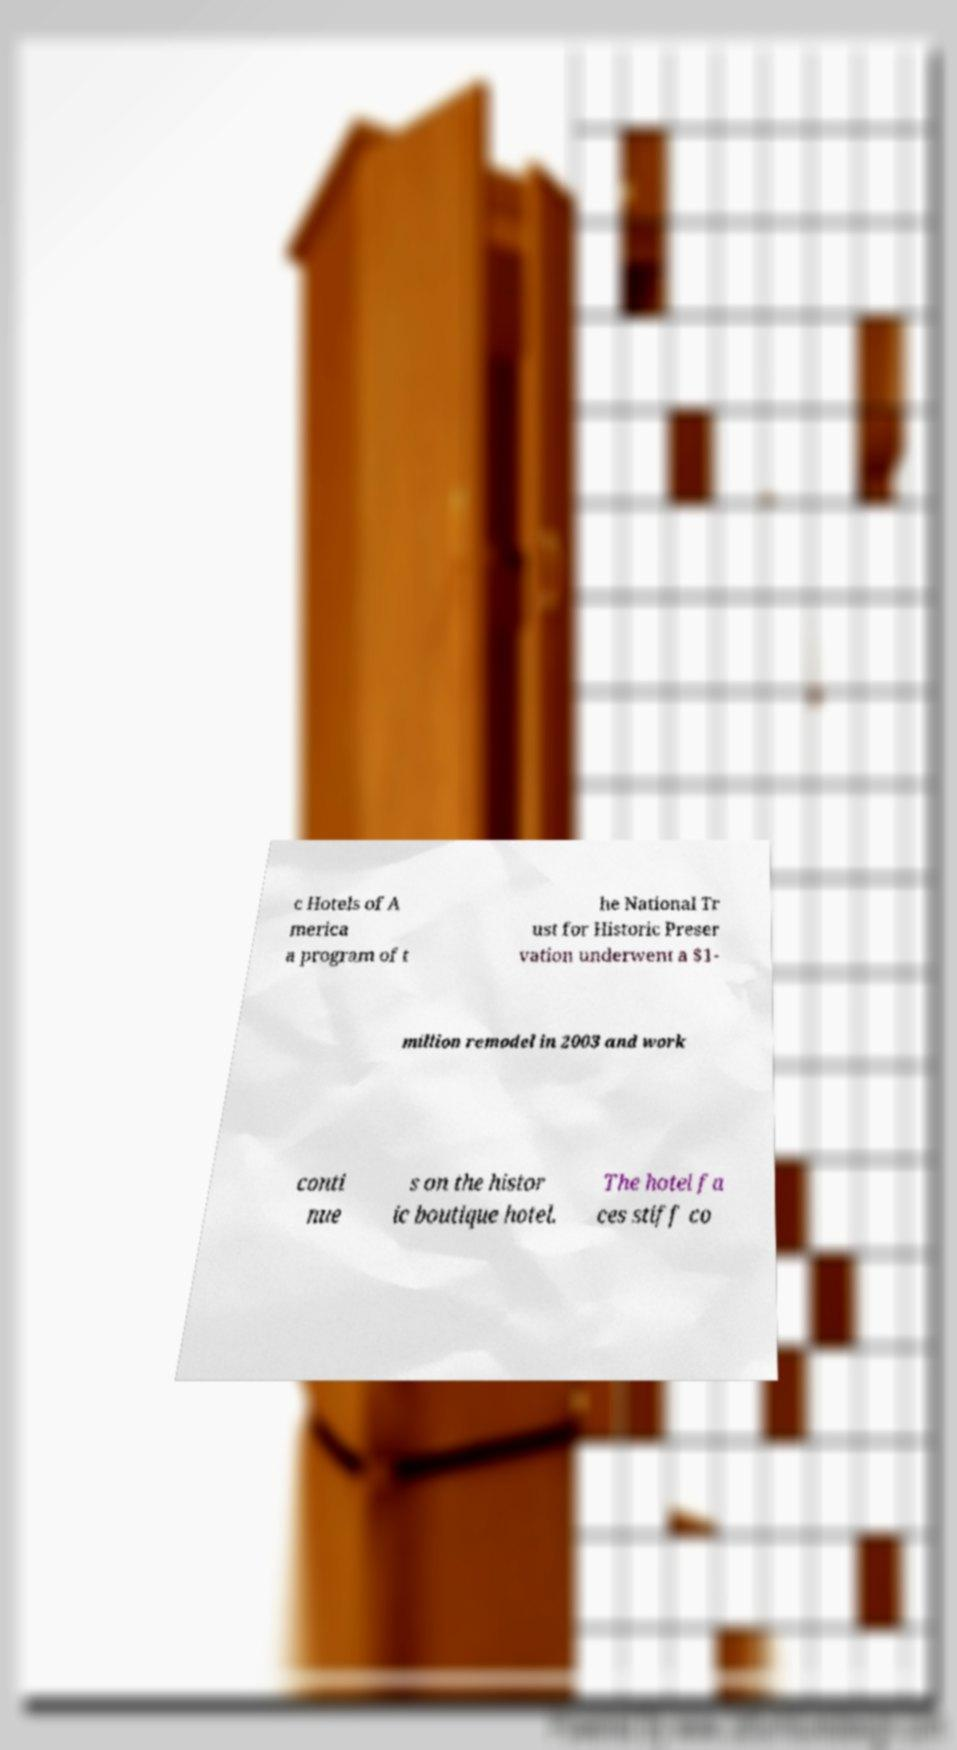For documentation purposes, I need the text within this image transcribed. Could you provide that? c Hotels of A merica a program of t he National Tr ust for Historic Preser vation underwent a $1- million remodel in 2003 and work conti nue s on the histor ic boutique hotel. The hotel fa ces stiff co 